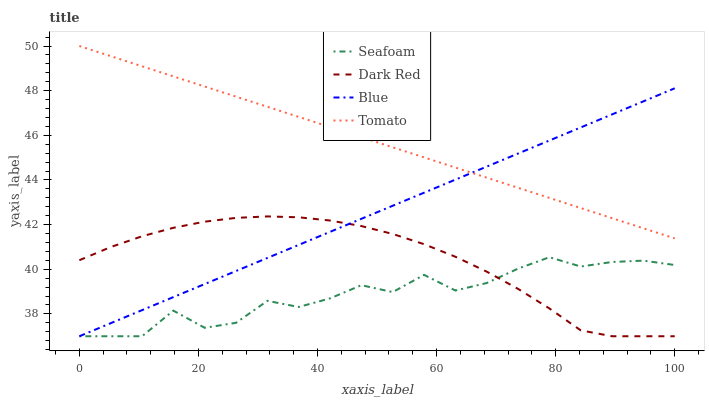Does Seafoam have the minimum area under the curve?
Answer yes or no. Yes. Does Tomato have the maximum area under the curve?
Answer yes or no. Yes. Does Dark Red have the minimum area under the curve?
Answer yes or no. No. Does Dark Red have the maximum area under the curve?
Answer yes or no. No. Is Blue the smoothest?
Answer yes or no. Yes. Is Seafoam the roughest?
Answer yes or no. Yes. Is Dark Red the smoothest?
Answer yes or no. No. Is Dark Red the roughest?
Answer yes or no. No. Does Blue have the lowest value?
Answer yes or no. Yes. Does Tomato have the lowest value?
Answer yes or no. No. Does Tomato have the highest value?
Answer yes or no. Yes. Does Dark Red have the highest value?
Answer yes or no. No. Is Seafoam less than Tomato?
Answer yes or no. Yes. Is Tomato greater than Dark Red?
Answer yes or no. Yes. Does Dark Red intersect Seafoam?
Answer yes or no. Yes. Is Dark Red less than Seafoam?
Answer yes or no. No. Is Dark Red greater than Seafoam?
Answer yes or no. No. Does Seafoam intersect Tomato?
Answer yes or no. No. 